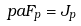<formula> <loc_0><loc_0><loc_500><loc_500>\ p a F _ { p } = J _ { p }</formula> 